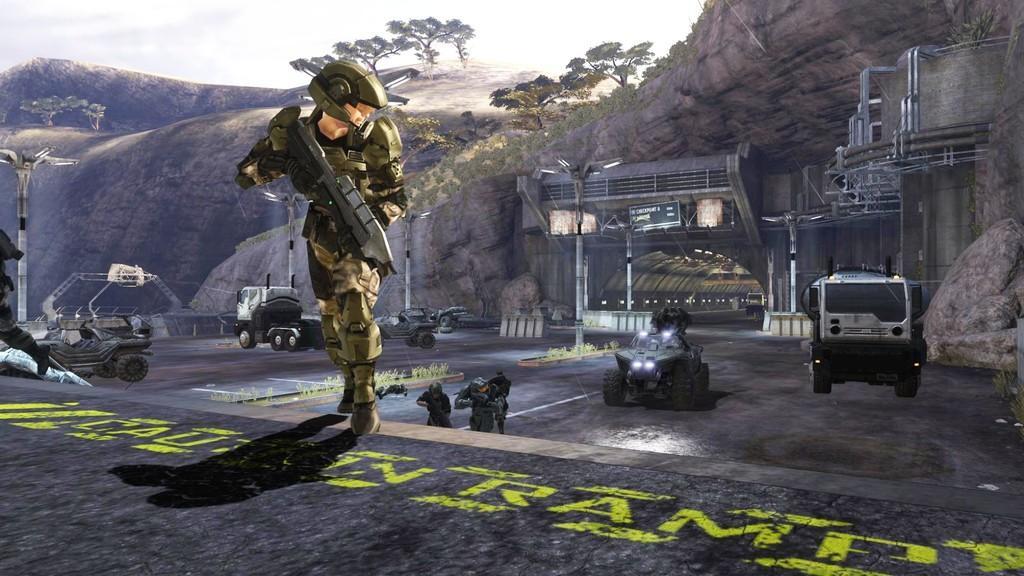In one or two sentences, can you explain what this image depicts? This is a graphic picture, in the picture I can see vehicles, person holding guns and there is the hill, on the hill I can see trees and there is street light pole, sign board and the sky at the top and a text visible on the road. 